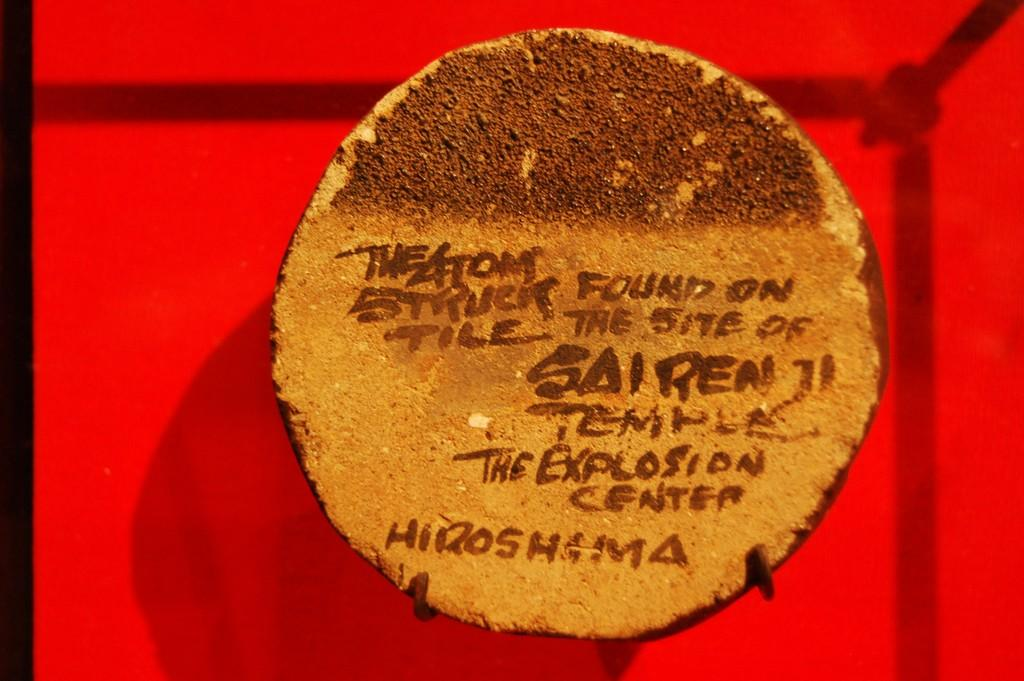What is the main subject of the image? A: There is a cake in the image. Are there any words or messages on the cake? Yes, there are letters written on the cake. Can you describe the shadow in the image? There is a shadow of an object in the image. What colors can be seen in the background of the image? The background has red and black colors. What type of trouble is the crook causing in the image? There is no crook or trouble depicted in the image; it features a cake with letters on it and a shadow. Is there a watch visible in the image? There is no watch present in the image. 